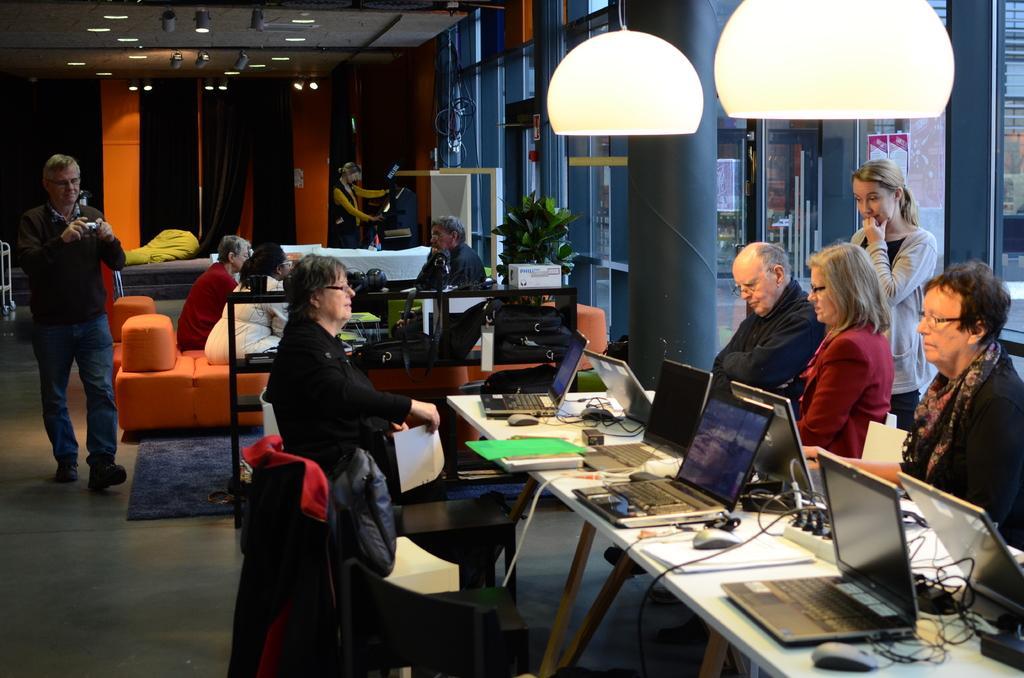Please provide a concise description of this image. There is a group of people. They are sitting on chairs. Some people are standing. There is a table. There is a laptop,mouse,battery,paper on a table. We can see in background lights,pillar and curtain. 